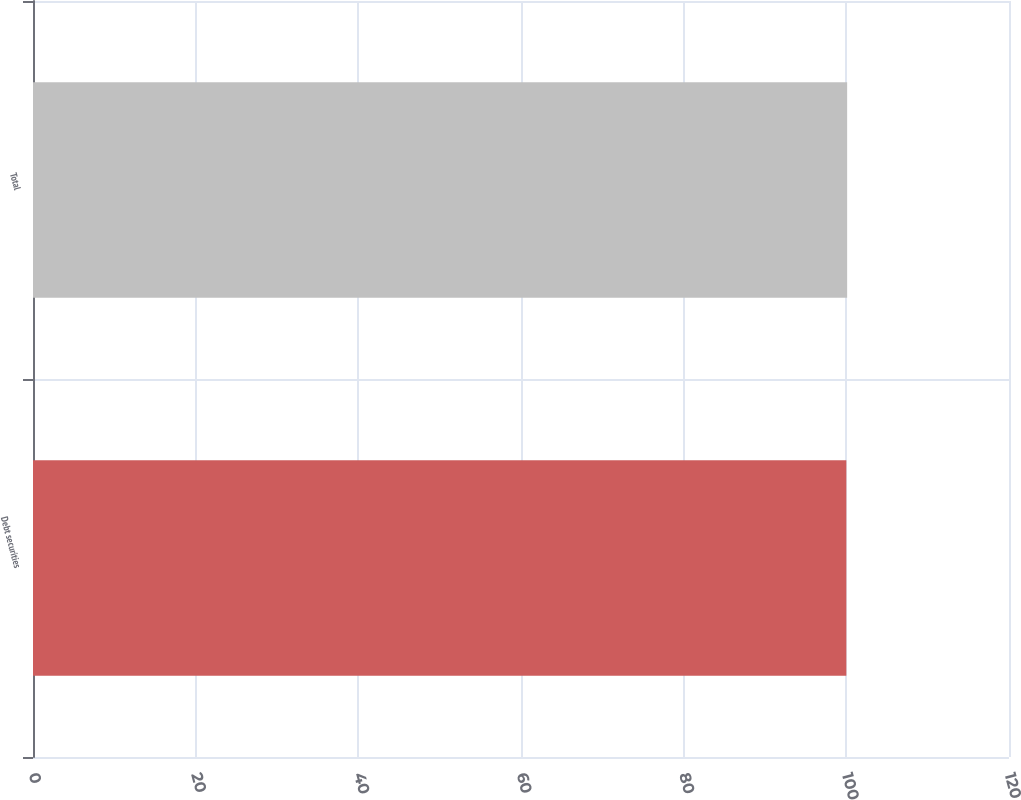Convert chart to OTSL. <chart><loc_0><loc_0><loc_500><loc_500><bar_chart><fcel>Debt securities<fcel>Total<nl><fcel>100<fcel>100.1<nl></chart> 